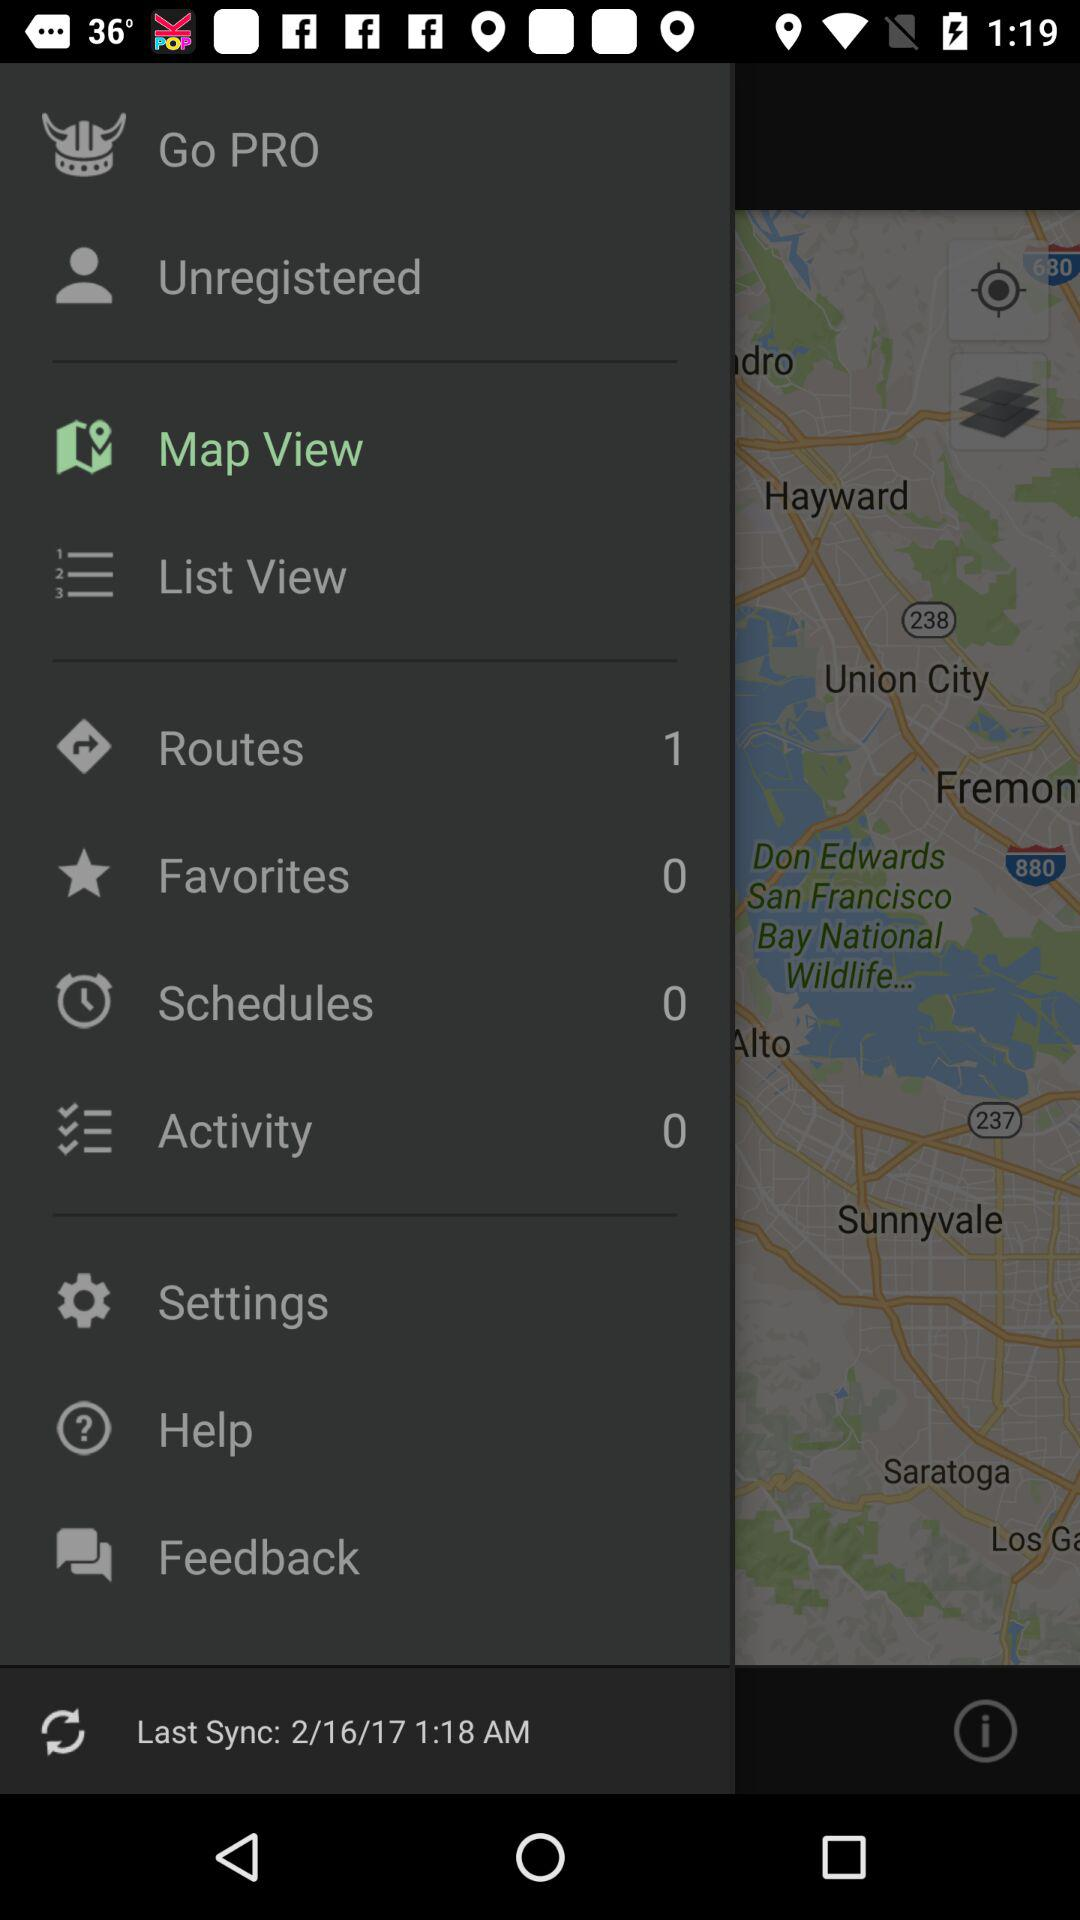What is the count of favorites? The count of favorites is 0. 